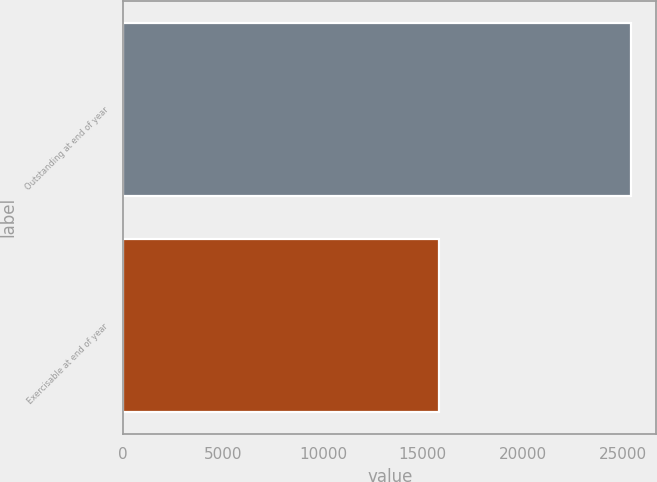Convert chart. <chart><loc_0><loc_0><loc_500><loc_500><bar_chart><fcel>Outstanding at end of year<fcel>Exercisable at end of year<nl><fcel>25418<fcel>15829<nl></chart> 